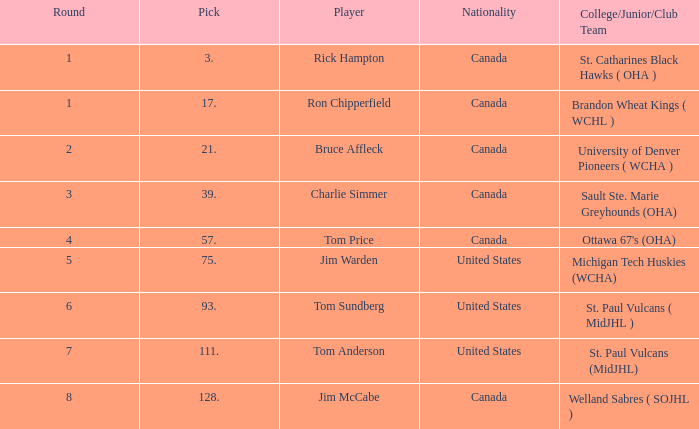Can you tell me the Nationality that has the Round smaller than 5, and the Player of bruce affleck? Canada. Parse the table in full. {'header': ['Round', 'Pick', 'Player', 'Nationality', 'College/Junior/Club Team'], 'rows': [['1', '3.', 'Rick Hampton', 'Canada', 'St. Catharines Black Hawks ( OHA )'], ['1', '17.', 'Ron Chipperfield', 'Canada', 'Brandon Wheat Kings ( WCHL )'], ['2', '21.', 'Bruce Affleck', 'Canada', 'University of Denver Pioneers ( WCHA )'], ['3', '39.', 'Charlie Simmer', 'Canada', 'Sault Ste. Marie Greyhounds (OHA)'], ['4', '57.', 'Tom Price', 'Canada', "Ottawa 67's (OHA)"], ['5', '75.', 'Jim Warden', 'United States', 'Michigan Tech Huskies (WCHA)'], ['6', '93.', 'Tom Sundberg', 'United States', 'St. Paul Vulcans ( MidJHL )'], ['7', '111.', 'Tom Anderson', 'United States', 'St. Paul Vulcans (MidJHL)'], ['8', '128.', 'Jim McCabe', 'Canada', 'Welland Sabres ( SOJHL )']]} 